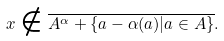<formula> <loc_0><loc_0><loc_500><loc_500>x \notin \overline { A ^ { \alpha } + \{ a - \alpha ( a ) | a \in A \} } .</formula> 